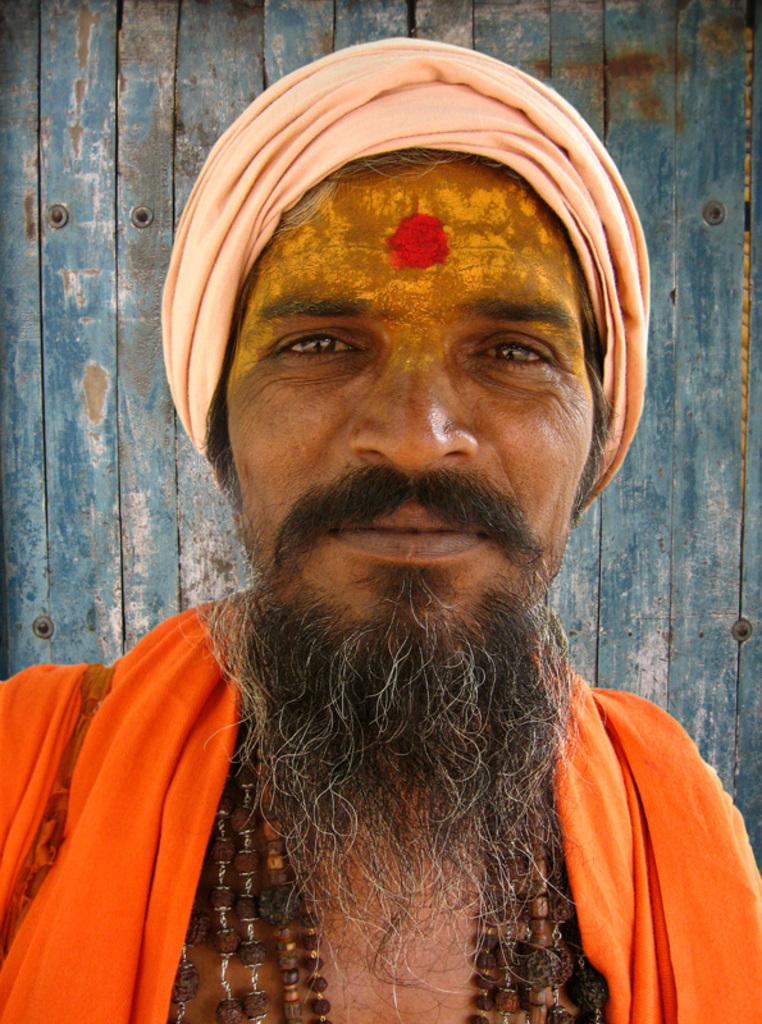Who is present in the image? There is a man in the image. What is the man's facial expression? The man is smiling. What can be seen in the background of the image? There is a wooden wall in the background of the image. What type of government is depicted in the image? There is no depiction of a government in the image; it features a man smiling in front of a wooden wall. How does the honey contribute to the image? There is no honey present in the image. 